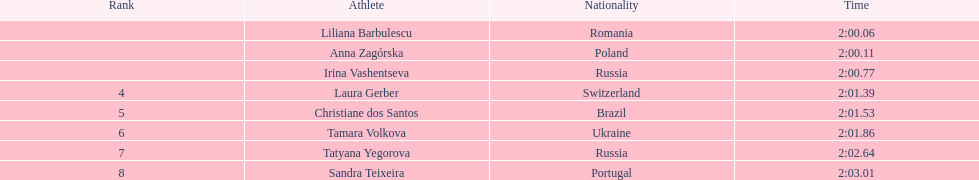The final participant passed the finish line at 2:0 2:02.64. 